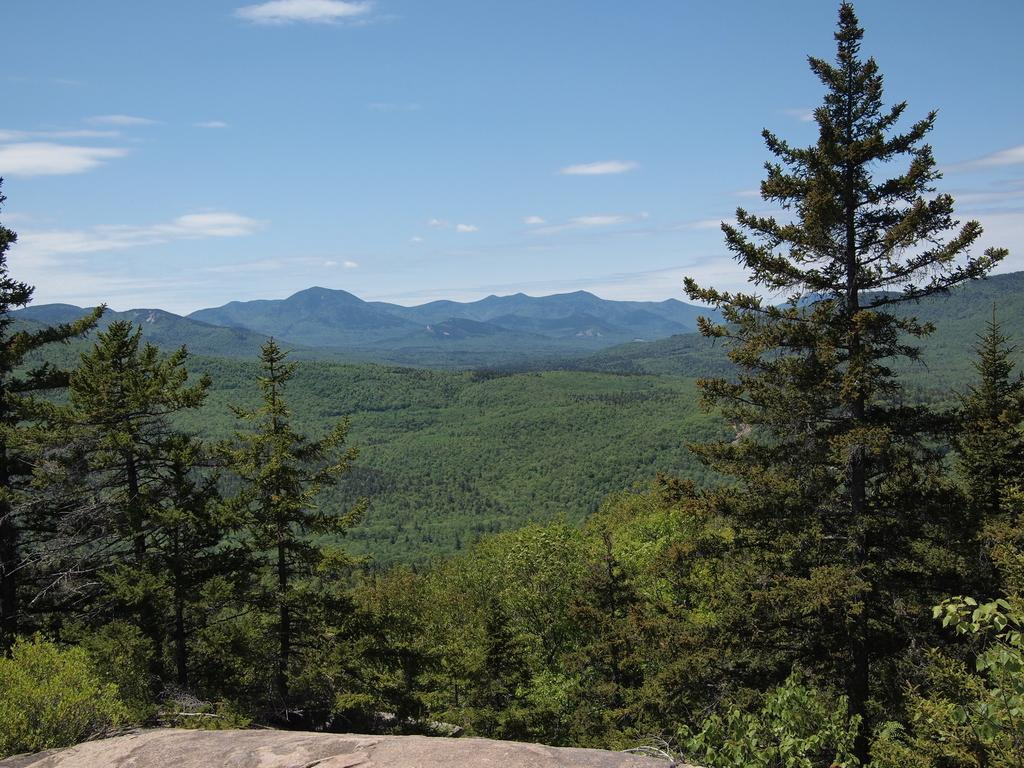What type of natural elements can be seen in the image? There are trees in the image. What type of landscape feature is visible in the background? There are mountains in the background of the image. What is the condition of the sky in the image? The sky is cloudy in the image. Where is the bridge located in the image? There is no bridge present in the image. What type of competition is taking place in the image? There is no competition present in the image. 